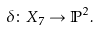Convert formula to latex. <formula><loc_0><loc_0><loc_500><loc_500>\delta \colon X _ { 7 } \rightarrow \mathbb { P } ^ { 2 } .</formula> 